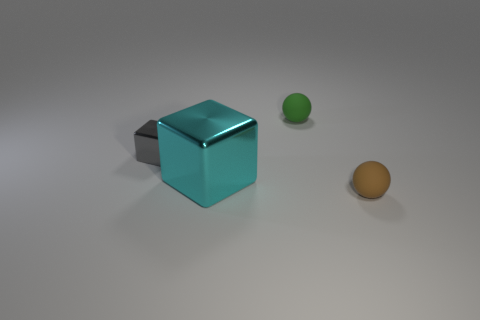Add 1 tiny metallic blocks. How many objects exist? 5 Subtract all red balls. How many yellow blocks are left? 0 Subtract all cyan blocks. How many blocks are left? 1 Subtract all big cyan blocks. Subtract all cyan metallic cubes. How many objects are left? 2 Add 4 green spheres. How many green spheres are left? 5 Add 3 matte balls. How many matte balls exist? 5 Subtract 0 yellow cylinders. How many objects are left? 4 Subtract 1 cubes. How many cubes are left? 1 Subtract all yellow blocks. Subtract all yellow balls. How many blocks are left? 2 